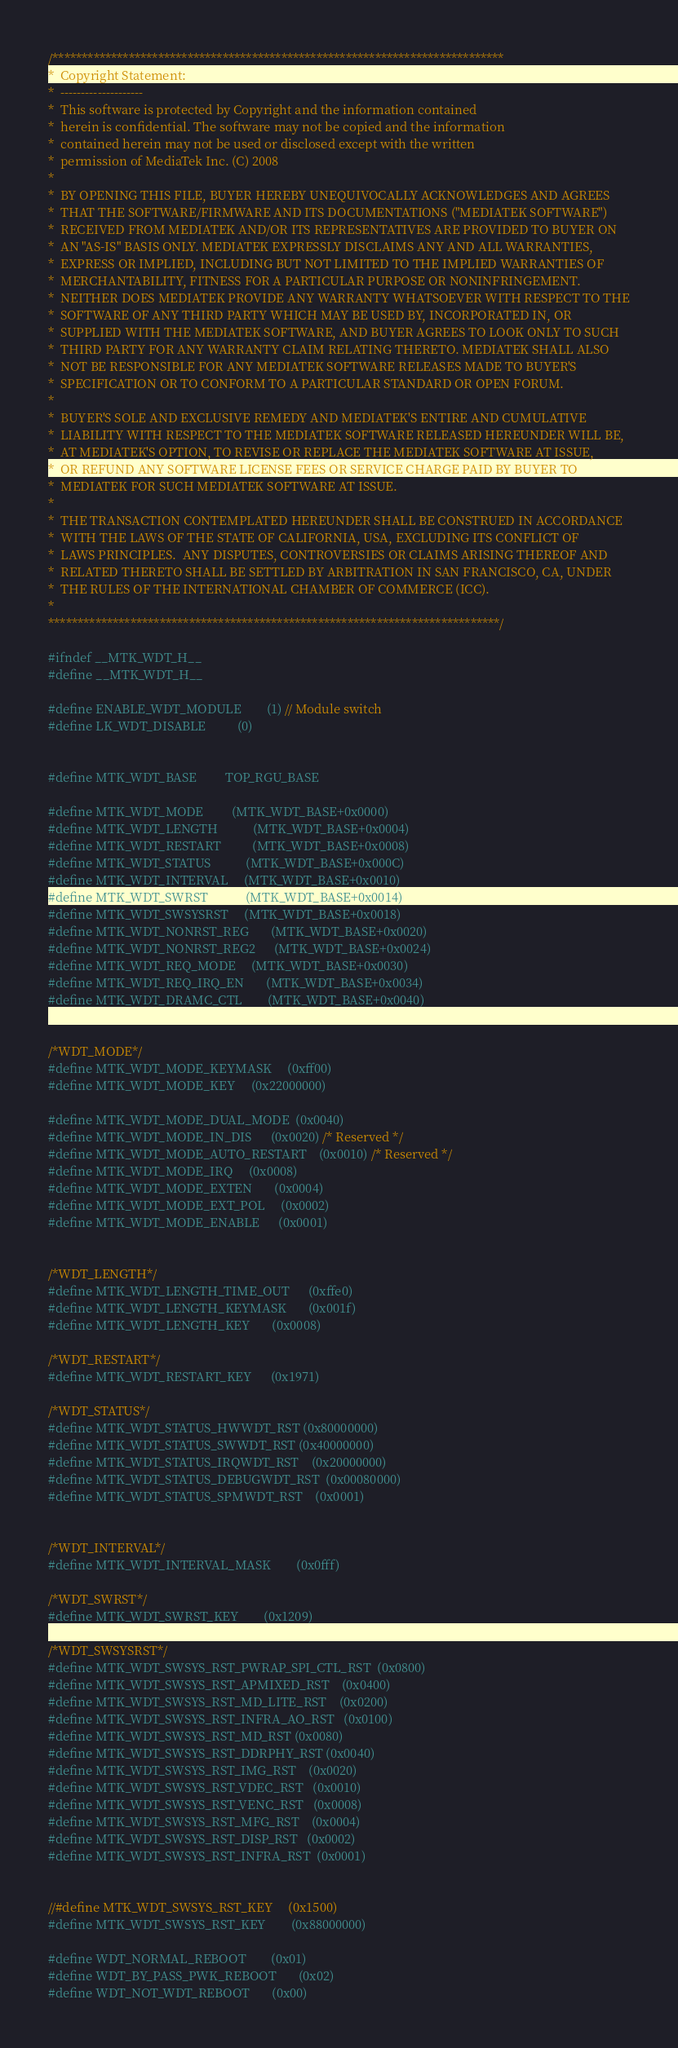<code> <loc_0><loc_0><loc_500><loc_500><_C_>/*****************************************************************************
*  Copyright Statement:
*  --------------------
*  This software is protected by Copyright and the information contained
*  herein is confidential. The software may not be copied and the information
*  contained herein may not be used or disclosed except with the written
*  permission of MediaTek Inc. (C) 2008
*
*  BY OPENING THIS FILE, BUYER HEREBY UNEQUIVOCALLY ACKNOWLEDGES AND AGREES
*  THAT THE SOFTWARE/FIRMWARE AND ITS DOCUMENTATIONS ("MEDIATEK SOFTWARE")
*  RECEIVED FROM MEDIATEK AND/OR ITS REPRESENTATIVES ARE PROVIDED TO BUYER ON
*  AN "AS-IS" BASIS ONLY. MEDIATEK EXPRESSLY DISCLAIMS ANY AND ALL WARRANTIES,
*  EXPRESS OR IMPLIED, INCLUDING BUT NOT LIMITED TO THE IMPLIED WARRANTIES OF
*  MERCHANTABILITY, FITNESS FOR A PARTICULAR PURPOSE OR NONINFRINGEMENT.
*  NEITHER DOES MEDIATEK PROVIDE ANY WARRANTY WHATSOEVER WITH RESPECT TO THE
*  SOFTWARE OF ANY THIRD PARTY WHICH MAY BE USED BY, INCORPORATED IN, OR
*  SUPPLIED WITH THE MEDIATEK SOFTWARE, AND BUYER AGREES TO LOOK ONLY TO SUCH
*  THIRD PARTY FOR ANY WARRANTY CLAIM RELATING THERETO. MEDIATEK SHALL ALSO
*  NOT BE RESPONSIBLE FOR ANY MEDIATEK SOFTWARE RELEASES MADE TO BUYER'S
*  SPECIFICATION OR TO CONFORM TO A PARTICULAR STANDARD OR OPEN FORUM.
*
*  BUYER'S SOLE AND EXCLUSIVE REMEDY AND MEDIATEK'S ENTIRE AND CUMULATIVE
*  LIABILITY WITH RESPECT TO THE MEDIATEK SOFTWARE RELEASED HEREUNDER WILL BE,
*  AT MEDIATEK'S OPTION, TO REVISE OR REPLACE THE MEDIATEK SOFTWARE AT ISSUE,
*  OR REFUND ANY SOFTWARE LICENSE FEES OR SERVICE CHARGE PAID BY BUYER TO
*  MEDIATEK FOR SUCH MEDIATEK SOFTWARE AT ISSUE. 
*
*  THE TRANSACTION CONTEMPLATED HEREUNDER SHALL BE CONSTRUED IN ACCORDANCE
*  WITH THE LAWS OF THE STATE OF CALIFORNIA, USA, EXCLUDING ITS CONFLICT OF
*  LAWS PRINCIPLES.  ANY DISPUTES, CONTROVERSIES OR CLAIMS ARISING THEREOF AND
*  RELATED THERETO SHALL BE SETTLED BY ARBITRATION IN SAN FRANCISCO, CA, UNDER
*  THE RULES OF THE INTERNATIONAL CHAMBER OF COMMERCE (ICC).
*
*****************************************************************************/

#ifndef __MTK_WDT_H__
#define __MTK_WDT_H__

#define ENABLE_WDT_MODULE		(1) // Module switch
#define LK_WDT_DISABLE          (0)


#define MTK_WDT_BASE			TOP_RGU_BASE

#define MTK_WDT_MODE			(MTK_WDT_BASE+0x0000)
#define MTK_WDT_LENGTH			(MTK_WDT_BASE+0x0004)
#define MTK_WDT_RESTART			(MTK_WDT_BASE+0x0008)
#define MTK_WDT_STATUS			(MTK_WDT_BASE+0x000C)
#define MTK_WDT_INTERVAL		(MTK_WDT_BASE+0x0010)
#define MTK_WDT_SWRST			(MTK_WDT_BASE+0x0014)
#define MTK_WDT_SWSYSRST		(MTK_WDT_BASE+0x0018)
#define MTK_WDT_NONRST_REG		(MTK_WDT_BASE+0x0020)
#define MTK_WDT_NONRST_REG2		(MTK_WDT_BASE+0x0024)
#define MTK_WDT_REQ_MODE		(MTK_WDT_BASE+0x0030)
#define MTK_WDT_REQ_IRQ_EN		(MTK_WDT_BASE+0x0034)
#define MTK_WDT_DRAMC_CTL		(MTK_WDT_BASE+0x0040)


/*WDT_MODE*/
#define MTK_WDT_MODE_KEYMASK		(0xff00)
#define MTK_WDT_MODE_KEY		(0x22000000)

#define MTK_WDT_MODE_DUAL_MODE  (0x0040)
#define MTK_WDT_MODE_IN_DIS		(0x0020) /* Reserved */
#define MTK_WDT_MODE_AUTO_RESTART	(0x0010) /* Reserved */
#define MTK_WDT_MODE_IRQ		(0x0008)
#define MTK_WDT_MODE_EXTEN		(0x0004)
#define MTK_WDT_MODE_EXT_POL		(0x0002)
#define MTK_WDT_MODE_ENABLE		(0x0001)


/*WDT_LENGTH*/
#define MTK_WDT_LENGTH_TIME_OUT		(0xffe0)
#define MTK_WDT_LENGTH_KEYMASK		(0x001f)
#define MTK_WDT_LENGTH_KEY		(0x0008)

/*WDT_RESTART*/
#define MTK_WDT_RESTART_KEY		(0x1971)

/*WDT_STATUS*/
#define MTK_WDT_STATUS_HWWDT_RST	(0x80000000)
#define MTK_WDT_STATUS_SWWDT_RST	(0x40000000)
#define MTK_WDT_STATUS_IRQWDT_RST	(0x20000000)
#define MTK_WDT_STATUS_DEBUGWDT_RST	(0x00080000)
#define MTK_WDT_STATUS_SPMWDT_RST	(0x0001)


/*WDT_INTERVAL*/
#define MTK_WDT_INTERVAL_MASK		(0x0fff)

/*WDT_SWRST*/
#define MTK_WDT_SWRST_KEY		(0x1209)

/*WDT_SWSYSRST*/
#define MTK_WDT_SWSYS_RST_PWRAP_SPI_CTL_RST	(0x0800)
#define MTK_WDT_SWSYS_RST_APMIXED_RST	(0x0400)
#define MTK_WDT_SWSYS_RST_MD_LITE_RST	(0x0200)
#define MTK_WDT_SWSYS_RST_INFRA_AO_RST	(0x0100)
#define MTK_WDT_SWSYS_RST_MD_RST	(0x0080)
#define MTK_WDT_SWSYS_RST_DDRPHY_RST	(0x0040)
#define MTK_WDT_SWSYS_RST_IMG_RST	(0x0020)
#define MTK_WDT_SWSYS_RST_VDEC_RST	(0x0010)
#define MTK_WDT_SWSYS_RST_VENC_RST	(0x0008)
#define MTK_WDT_SWSYS_RST_MFG_RST	(0x0004)
#define MTK_WDT_SWSYS_RST_DISP_RST	(0x0002)
#define MTK_WDT_SWSYS_RST_INFRA_RST	(0x0001)


//#define MTK_WDT_SWSYS_RST_KEY		(0x1500)
#define MTK_WDT_SWSYS_RST_KEY		(0x88000000)

#define WDT_NORMAL_REBOOT		(0x01)
#define WDT_BY_PASS_PWK_REBOOT		(0x02)
#define WDT_NOT_WDT_REBOOT		(0x00)
</code> 